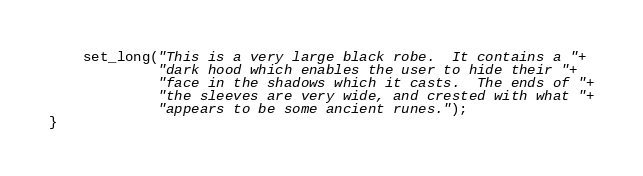Convert code to text. <code><loc_0><loc_0><loc_500><loc_500><_C_>    set_long("This is a very large black robe.  It contains a "+
             "dark hood which enables the user to hide their "+
             "face in the shadows which it casts.  The ends of "+
             "the sleeves are very wide, and crested with what "+
             "appears to be some ancient runes.");
}
</code> 